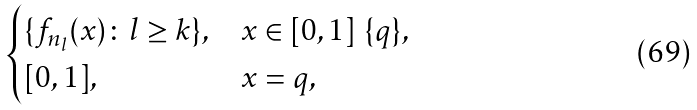Convert formula to latex. <formula><loc_0><loc_0><loc_500><loc_500>\begin{cases} \{ f _ { n _ { l } } ( x ) \colon l \geq k \} , & x \in [ 0 , 1 ] \ \{ q \} , \\ [ 0 , 1 ] , & x = q , \end{cases}</formula> 